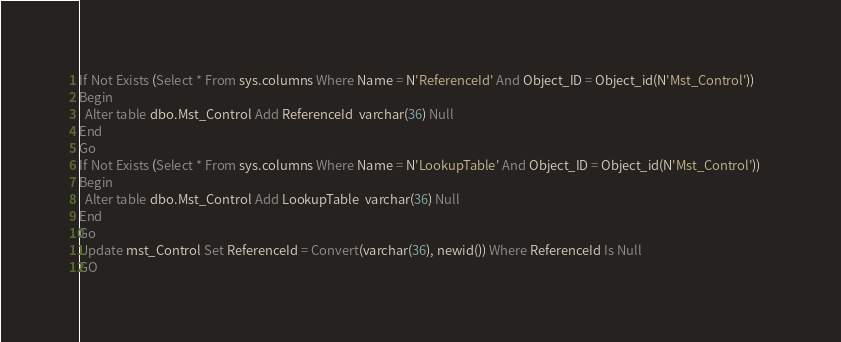<code> <loc_0><loc_0><loc_500><loc_500><_SQL_>If Not Exists (Select * From sys.columns Where Name = N'ReferenceId' And Object_ID = Object_id(N'Mst_Control'))    
Begin
  Alter table dbo.Mst_Control Add ReferenceId  varchar(36) Null 
End
Go
If Not Exists (Select * From sys.columns Where Name = N'LookupTable' And Object_ID = Object_id(N'Mst_Control'))    
Begin
  Alter table dbo.Mst_Control Add LookupTable  varchar(36) Null 
End
Go
Update mst_Control Set ReferenceId = Convert(varchar(36), newid()) Where ReferenceId Is Null
GO</code> 